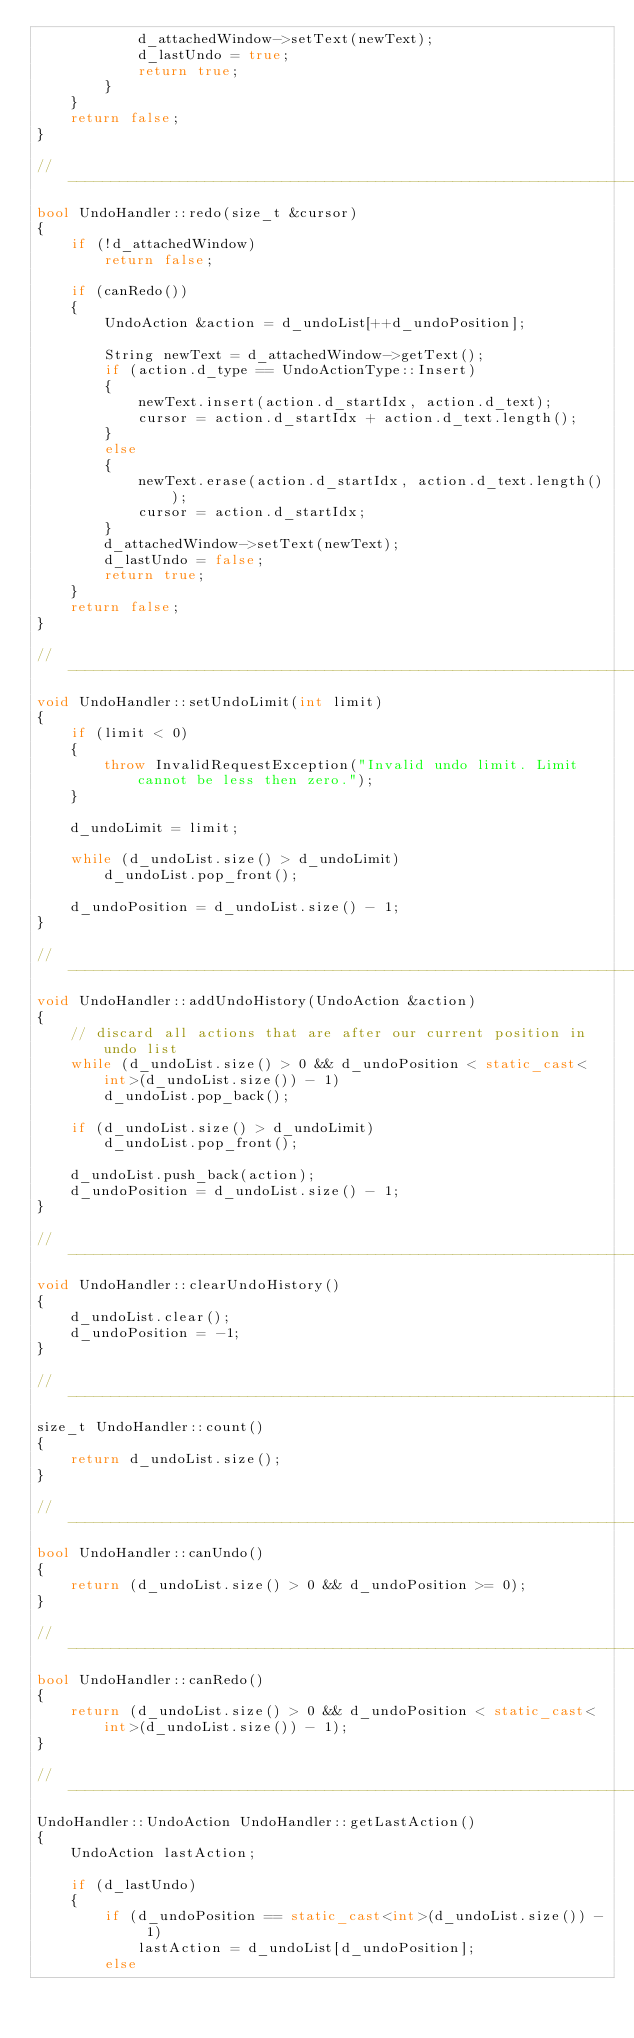Convert code to text. <code><loc_0><loc_0><loc_500><loc_500><_C++_>            d_attachedWindow->setText(newText);
            d_lastUndo = true;
            return true;
        }
    }
    return false;
}

//----------------------------------------------------------------------------//
bool UndoHandler::redo(size_t &cursor)
{
    if (!d_attachedWindow)
        return false;

    if (canRedo())
    {
        UndoAction &action = d_undoList[++d_undoPosition];

        String newText = d_attachedWindow->getText();
        if (action.d_type == UndoActionType::Insert)
        {
            newText.insert(action.d_startIdx, action.d_text);
            cursor = action.d_startIdx + action.d_text.length();
        }
        else
        {
            newText.erase(action.d_startIdx, action.d_text.length());
            cursor = action.d_startIdx;
        }
        d_attachedWindow->setText(newText);
        d_lastUndo = false;
        return true;
    }
    return false;
}

//----------------------------------------------------------------------------//
void UndoHandler::setUndoLimit(int limit)
{
    if (limit < 0)
    {
        throw InvalidRequestException("Invalid undo limit. Limit cannot be less then zero.");
    }

    d_undoLimit = limit;

    while (d_undoList.size() > d_undoLimit)
        d_undoList.pop_front();

    d_undoPosition = d_undoList.size() - 1;
}

//----------------------------------------------------------------------------//
void UndoHandler::addUndoHistory(UndoAction &action)
{
    // discard all actions that are after our current position in undo list
    while (d_undoList.size() > 0 && d_undoPosition < static_cast<int>(d_undoList.size()) - 1)
        d_undoList.pop_back();

    if (d_undoList.size() > d_undoLimit)
        d_undoList.pop_front();

    d_undoList.push_back(action);
    d_undoPosition = d_undoList.size() - 1;
}

//----------------------------------------------------------------------------//
void UndoHandler::clearUndoHistory()
{
    d_undoList.clear();
    d_undoPosition = -1;
}

//----------------------------------------------------------------------------//
size_t UndoHandler::count()
{
    return d_undoList.size();
}

//----------------------------------------------------------------------------//
bool UndoHandler::canUndo()
{
    return (d_undoList.size() > 0 && d_undoPosition >= 0);
}

//----------------------------------------------------------------------------//
bool UndoHandler::canRedo()
{
    return (d_undoList.size() > 0 && d_undoPosition < static_cast<int>(d_undoList.size()) - 1);
}

//----------------------------------------------------------------------------//
UndoHandler::UndoAction UndoHandler::getLastAction()
{
    UndoAction lastAction;

    if (d_lastUndo)
    {
        if (d_undoPosition == static_cast<int>(d_undoList.size()) - 1)
            lastAction = d_undoList[d_undoPosition];
        else</code> 